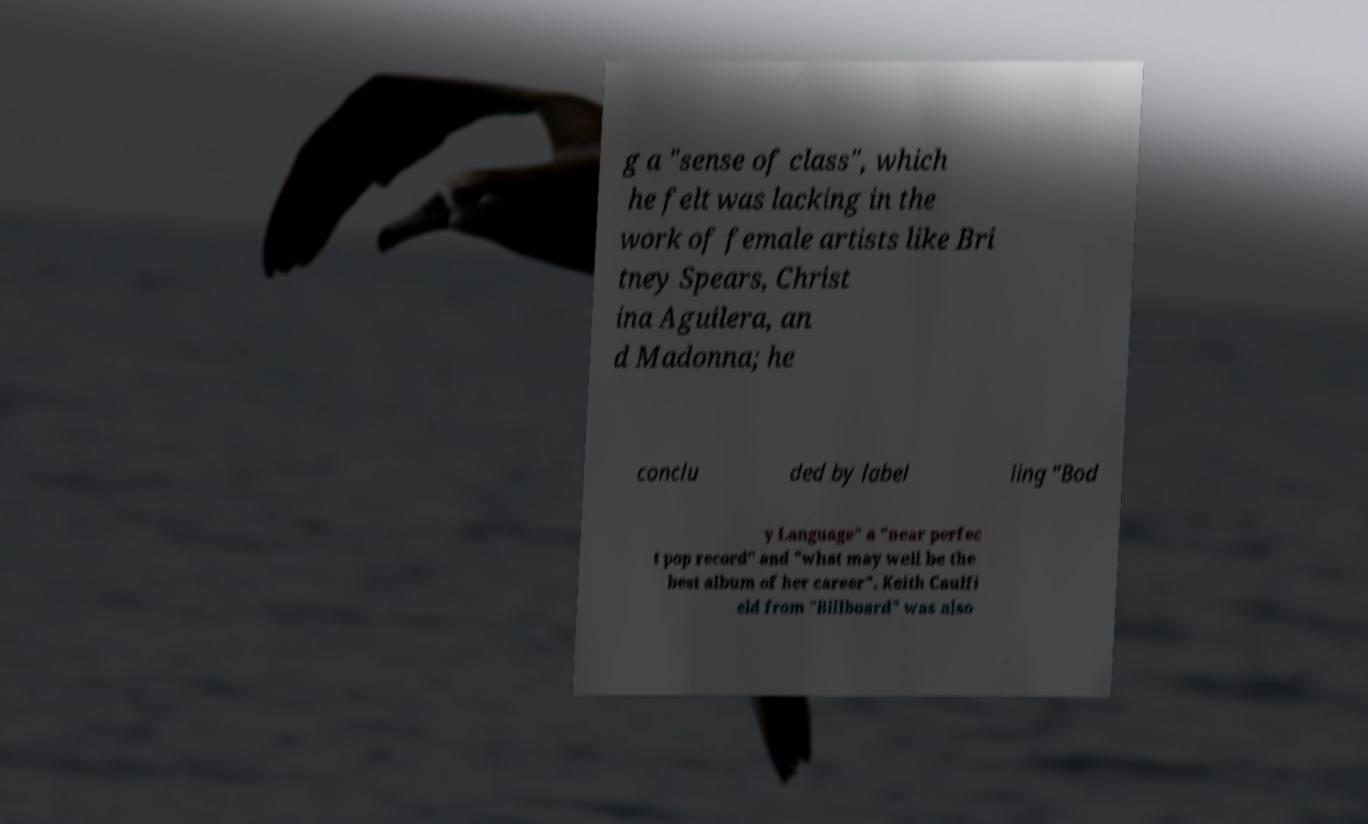Can you accurately transcribe the text from the provided image for me? g a "sense of class", which he felt was lacking in the work of female artists like Bri tney Spears, Christ ina Aguilera, an d Madonna; he conclu ded by label ling "Bod y Language" a "near perfec t pop record" and "what may well be the best album of her career". Keith Caulfi eld from "Billboard" was also 